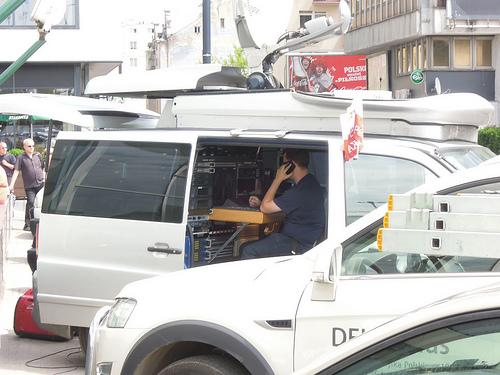Identify the primary activity happening in the image. A man is talking on the phone while sitting inside a van. List any objects related to food in the image. There are no visible objects related to food in the image. What does the man leaning on something wear? The man is wearing a dark blue shirt. How many instances of people are there in the image, and what are their main activities? There is one man visible in the image, and he is talking on the phone while sitting inside a van. Explain the status of the cars in the image. The van in the image is parked, and the man inside is using the phone. Assess the quality of the image in terms of details provided. The image quality is moderate, allowing for identification of the main activity and some details of the scene. How many buildings have glass windows, and what color are they? The image does not provide a clear view of any buildings to assess the windows or their colors. Write a caption summarizing the visual content of the image. A man talks on the phone inside a parked van on a city street. Determine the sentiment evoked by the image. The sentiment evoked by the image is one of everyday urban activity, possibly indicating a work-related scenario. Identify any specific brands or logos present in the image. There are no clearly visible brands or logos in the image. Can you spot a blue and yellow sign in the image? There is no blue and yellow sign visible in the image. Can you notice the dog standing on the road in the image? There is no dog visible in the image. Can you find a woman wearing a blue shirt and pants in the image? There is no woman visible in the image. Can you find an object in the image with a fish bowl on it? There are no objects with a fish bowl visible in the image. Can you locate the broken glass window on a vehicle in the image? There is no broken glass window visible on any vehicle in the image. Can you locate the purple door of a car in the image? There is no purple door visible on any car in the image. 